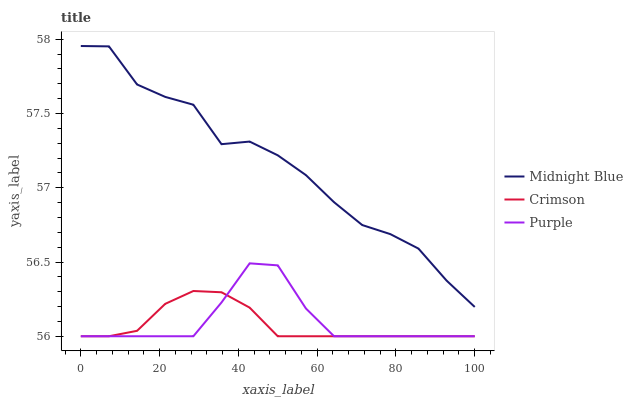Does Crimson have the minimum area under the curve?
Answer yes or no. Yes. Does Midnight Blue have the maximum area under the curve?
Answer yes or no. Yes. Does Purple have the minimum area under the curve?
Answer yes or no. No. Does Purple have the maximum area under the curve?
Answer yes or no. No. Is Crimson the smoothest?
Answer yes or no. Yes. Is Midnight Blue the roughest?
Answer yes or no. Yes. Is Purple the smoothest?
Answer yes or no. No. Is Purple the roughest?
Answer yes or no. No. Does Crimson have the lowest value?
Answer yes or no. Yes. Does Midnight Blue have the lowest value?
Answer yes or no. No. Does Midnight Blue have the highest value?
Answer yes or no. Yes. Does Purple have the highest value?
Answer yes or no. No. Is Purple less than Midnight Blue?
Answer yes or no. Yes. Is Midnight Blue greater than Crimson?
Answer yes or no. Yes. Does Purple intersect Crimson?
Answer yes or no. Yes. Is Purple less than Crimson?
Answer yes or no. No. Is Purple greater than Crimson?
Answer yes or no. No. Does Purple intersect Midnight Blue?
Answer yes or no. No. 